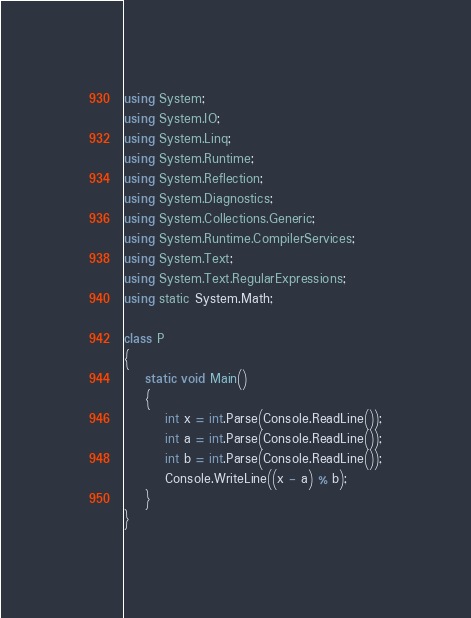<code> <loc_0><loc_0><loc_500><loc_500><_C#_>using System;
using System.IO;
using System.Linq;
using System.Runtime;
using System.Reflection;
using System.Diagnostics;
using System.Collections.Generic;
using System.Runtime.CompilerServices;
using System.Text;
using System.Text.RegularExpressions;
using static System.Math;

class P
{
    static void Main()
    {
        int x = int.Parse(Console.ReadLine());
        int a = int.Parse(Console.ReadLine());
        int b = int.Parse(Console.ReadLine());
        Console.WriteLine((x - a) % b);
    }
}</code> 